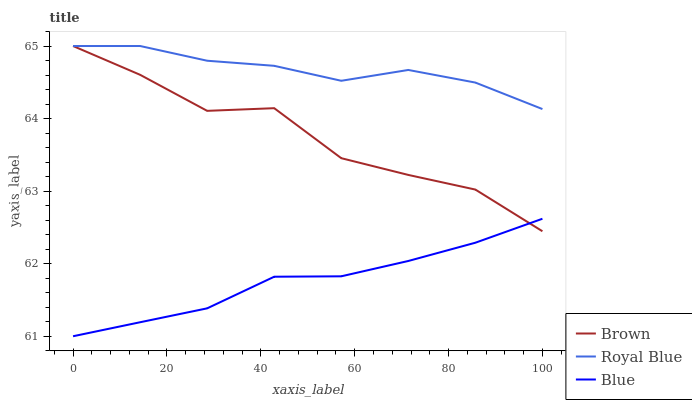Does Blue have the minimum area under the curve?
Answer yes or no. Yes. Does Royal Blue have the maximum area under the curve?
Answer yes or no. Yes. Does Brown have the minimum area under the curve?
Answer yes or no. No. Does Brown have the maximum area under the curve?
Answer yes or no. No. Is Blue the smoothest?
Answer yes or no. Yes. Is Brown the roughest?
Answer yes or no. Yes. Is Royal Blue the smoothest?
Answer yes or no. No. Is Royal Blue the roughest?
Answer yes or no. No. Does Blue have the lowest value?
Answer yes or no. Yes. Does Brown have the lowest value?
Answer yes or no. No. Does Royal Blue have the highest value?
Answer yes or no. Yes. Is Blue less than Royal Blue?
Answer yes or no. Yes. Is Royal Blue greater than Blue?
Answer yes or no. Yes. Does Brown intersect Royal Blue?
Answer yes or no. Yes. Is Brown less than Royal Blue?
Answer yes or no. No. Is Brown greater than Royal Blue?
Answer yes or no. No. Does Blue intersect Royal Blue?
Answer yes or no. No. 